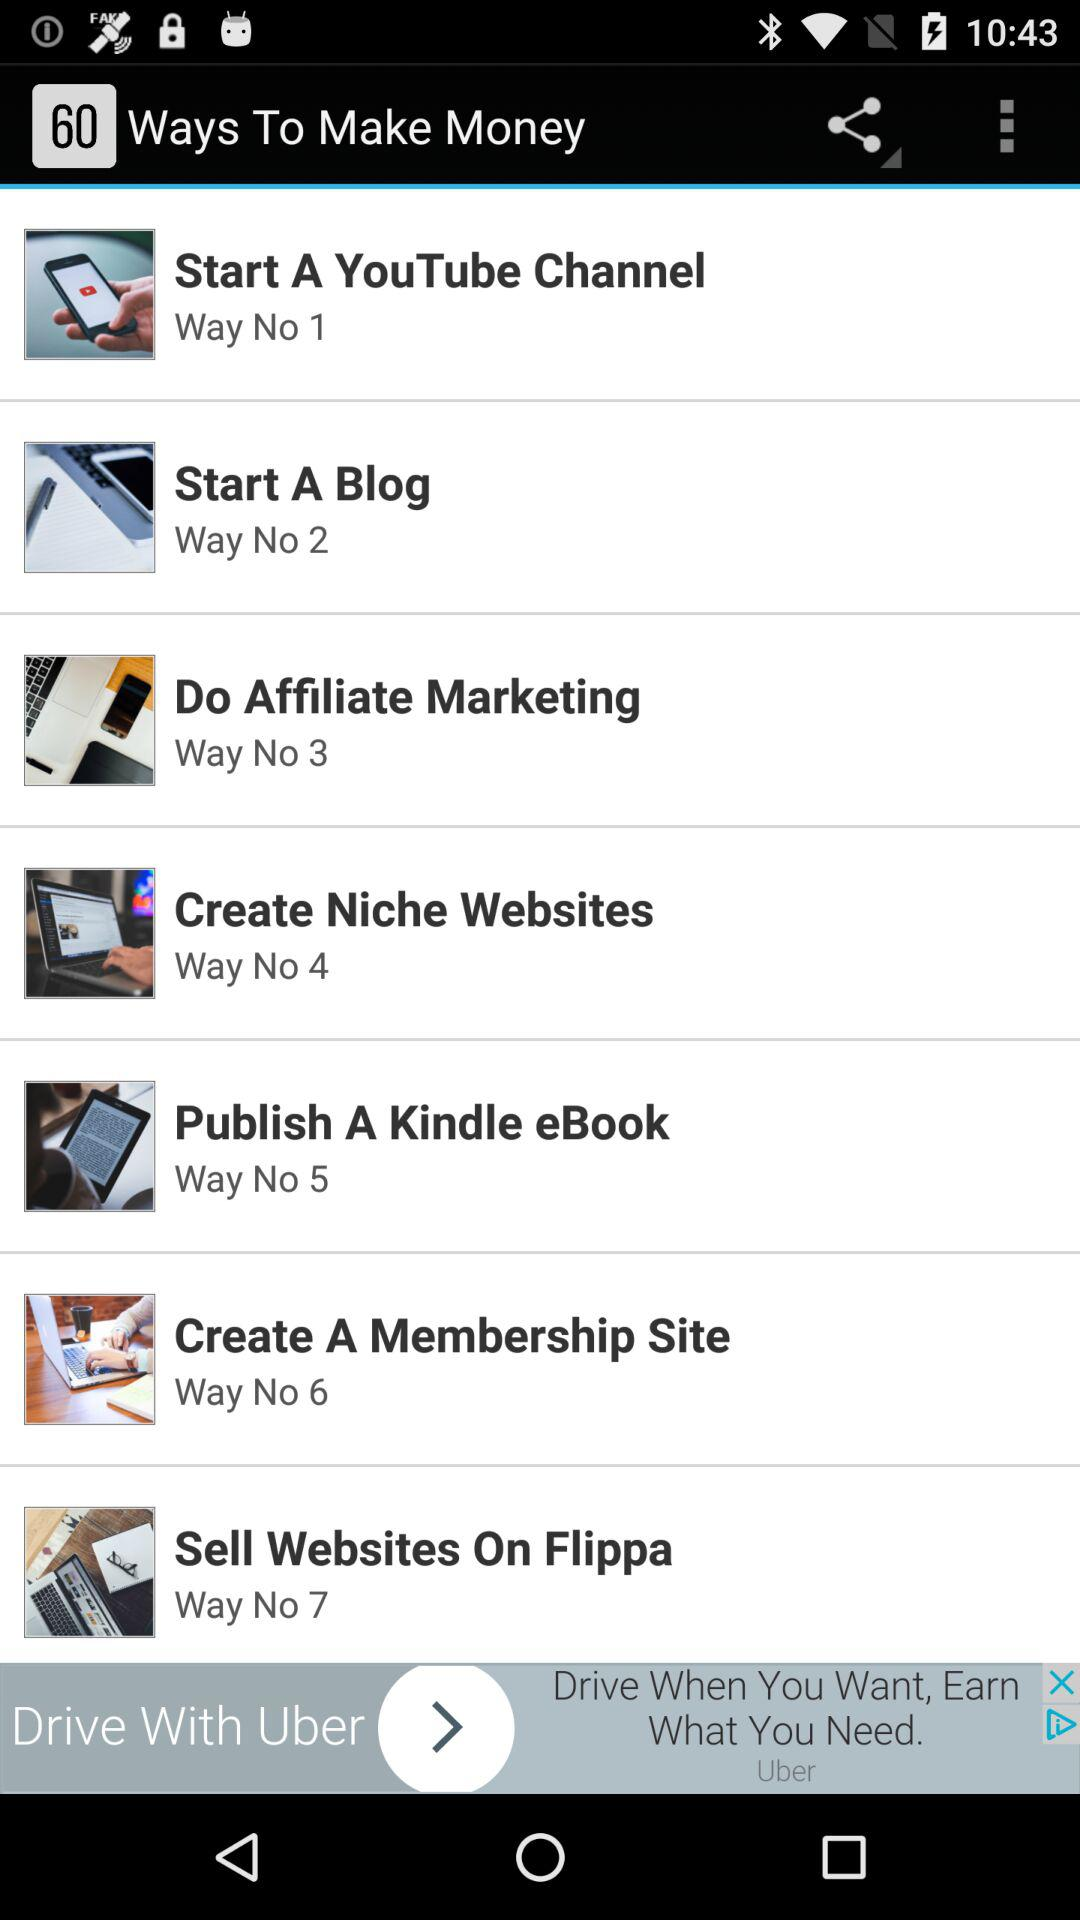How many ways are there to make money? There are 60 ways to make money. 